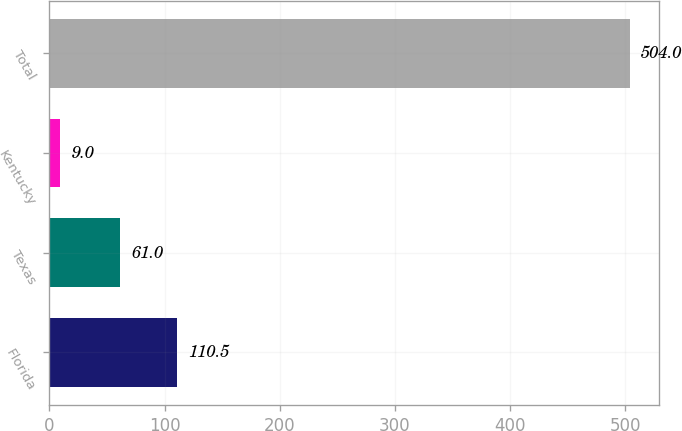Convert chart to OTSL. <chart><loc_0><loc_0><loc_500><loc_500><bar_chart><fcel>Florida<fcel>Texas<fcel>Kentucky<fcel>Total<nl><fcel>110.5<fcel>61<fcel>9<fcel>504<nl></chart> 